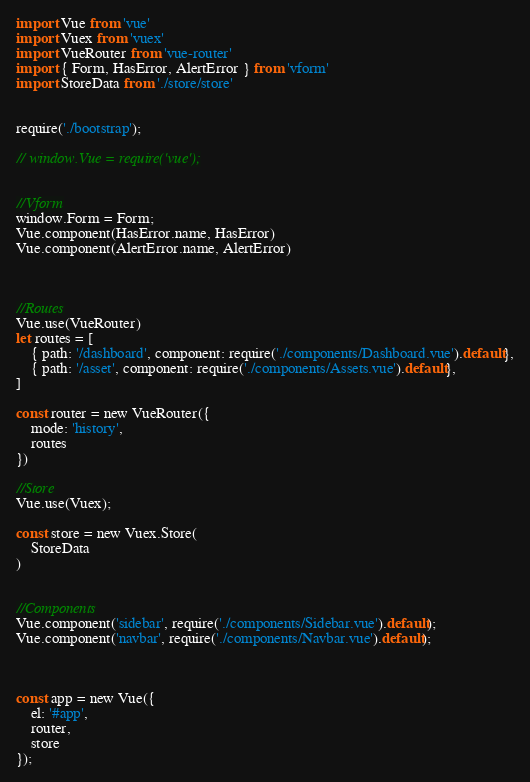Convert code to text. <code><loc_0><loc_0><loc_500><loc_500><_JavaScript_>import Vue from 'vue'
import Vuex from 'vuex'
import VueRouter from 'vue-router'
import { Form, HasError, AlertError } from 'vform'
import StoreData from './store/store'


require('./bootstrap');

// window.Vue = require('vue');


//Vform
window.Form = Form;
Vue.component(HasError.name, HasError)
Vue.component(AlertError.name, AlertError)



//Routes
Vue.use(VueRouter)
let routes = [
    { path: '/dashboard', component: require('./components/Dashboard.vue').default},
    { path: '/asset', component: require('./components/Assets.vue').default},
]

const router = new VueRouter({
    mode: 'history',
    routes
})

//Store
Vue.use(Vuex);

const store = new Vuex.Store(
    StoreData
)


//Components
Vue.component('sidebar', require('./components/Sidebar.vue').default);
Vue.component('navbar', require('./components/Navbar.vue').default);



const app = new Vue({
    el: '#app',
    router,
    store
});
</code> 